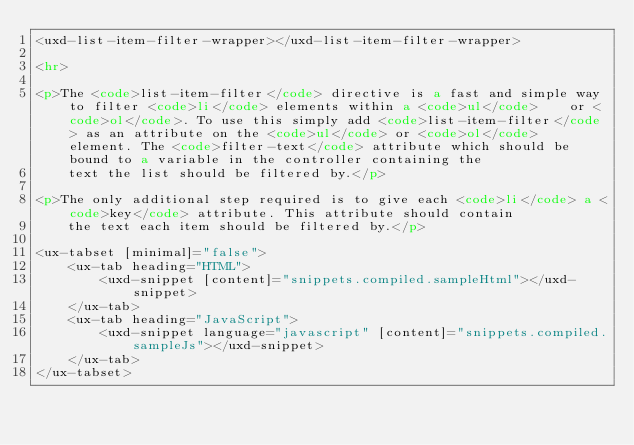Convert code to text. <code><loc_0><loc_0><loc_500><loc_500><_HTML_><uxd-list-item-filter-wrapper></uxd-list-item-filter-wrapper>

<hr>

<p>The <code>list-item-filter</code> directive is a fast and simple way to filter <code>li</code> elements within a <code>ul</code>    or <code>ol</code>. To use this simply add <code>list-item-filter</code> as an attribute on the <code>ul</code> or <code>ol</code>    element. The <code>filter-text</code> attribute which should be bound to a variable in the controller containing the
    text the list should be filtered by.</p>

<p>The only additional step required is to give each <code>li</code> a <code>key</code> attribute. This attribute should contain
    the text each item should be filtered by.</p>

<ux-tabset [minimal]="false">
    <ux-tab heading="HTML">
        <uxd-snippet [content]="snippets.compiled.sampleHtml"></uxd-snippet>
    </ux-tab>
    <ux-tab heading="JavaScript">
        <uxd-snippet language="javascript" [content]="snippets.compiled.sampleJs"></uxd-snippet>
    </ux-tab>
</ux-tabset></code> 